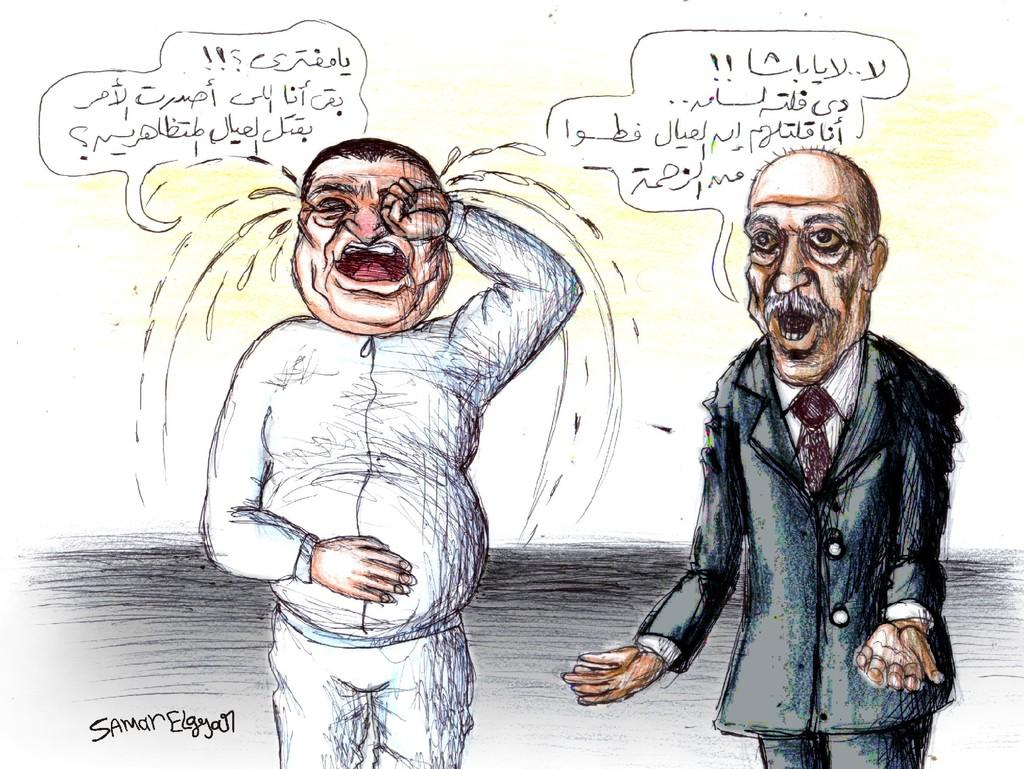What type of image is present in the picture? There is a comic in the image. Can you describe the characters in the comic? The comic features an old man in a suit on the right side and another man in a white dress on the left side. What is the emotional state of the man in the white dress? The man in the white dress is crying. Is there any text associated with the comic? Yes, there is text above the comic. What type of lumber is being used to build the road in the image? There is no road or lumber present in the image; it features a comic with two characters. Can you tell me how many drums are visible in the image? There are no drums present in the image; it features a comic with two characters and text. 